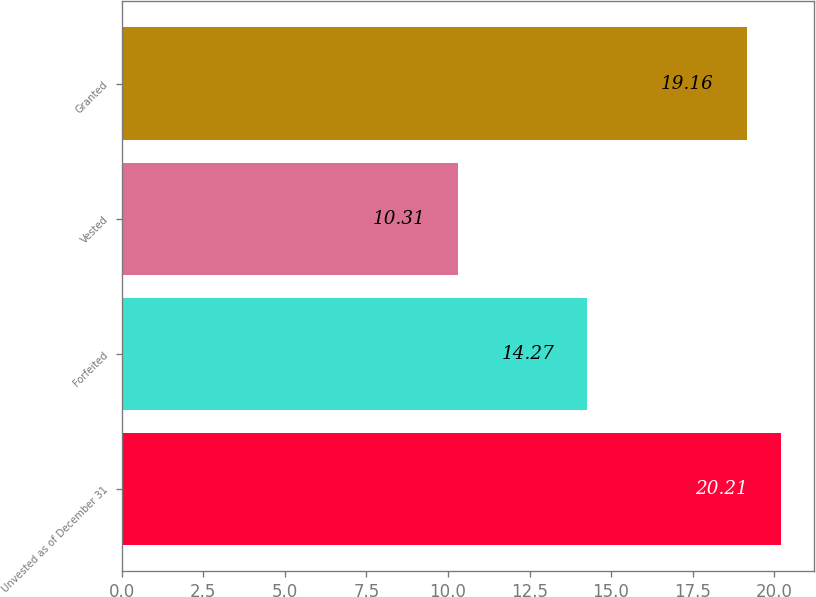Convert chart to OTSL. <chart><loc_0><loc_0><loc_500><loc_500><bar_chart><fcel>Unvested as of December 31<fcel>Forfeited<fcel>Vested<fcel>Granted<nl><fcel>20.21<fcel>14.27<fcel>10.31<fcel>19.16<nl></chart> 